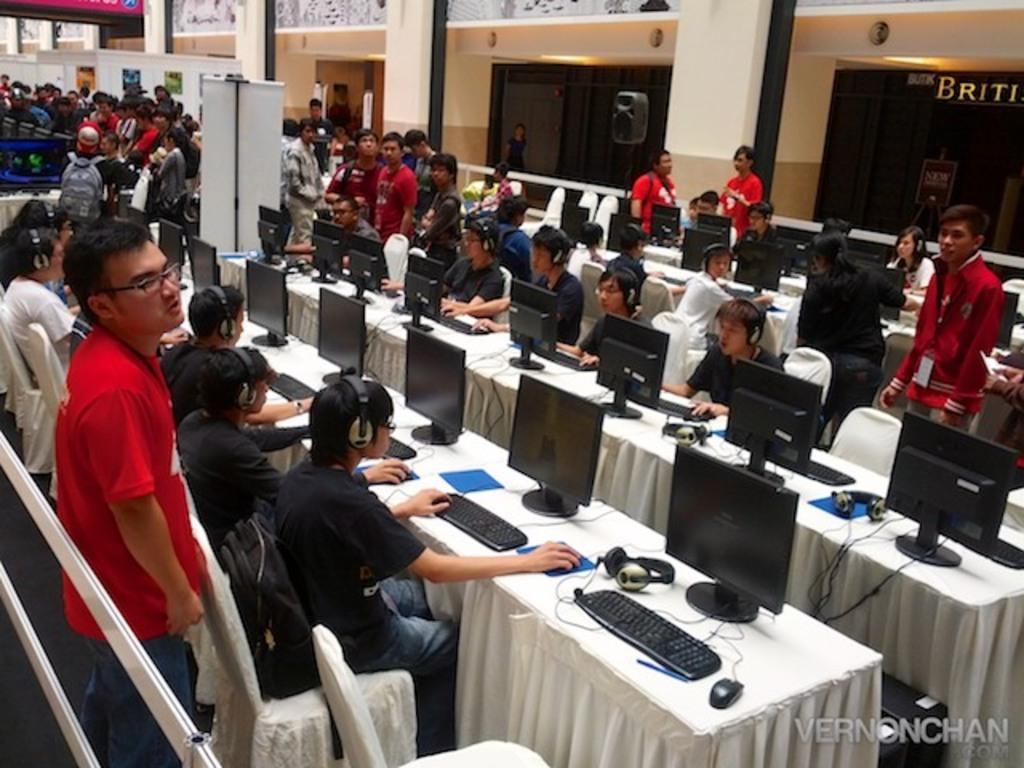What is happening in the image involving a group of people? There is a group of people in the image, and they are sitting in front of a system. What are the people wearing in the image? The people in the image are wearing headsets. How much water is needed to wash the system in the image? There is no indication in the image that the system needs to be washed, and the amount of water required cannot be determined. 